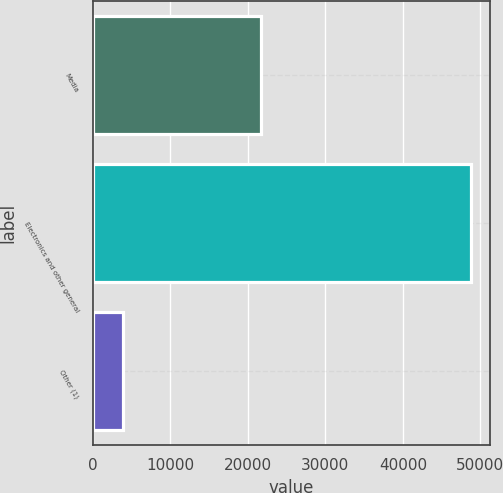Convert chart. <chart><loc_0><loc_0><loc_500><loc_500><bar_chart><fcel>Media<fcel>Electronics and other general<fcel>Other (1)<nl><fcel>21716<fcel>48802<fcel>3934<nl></chart> 